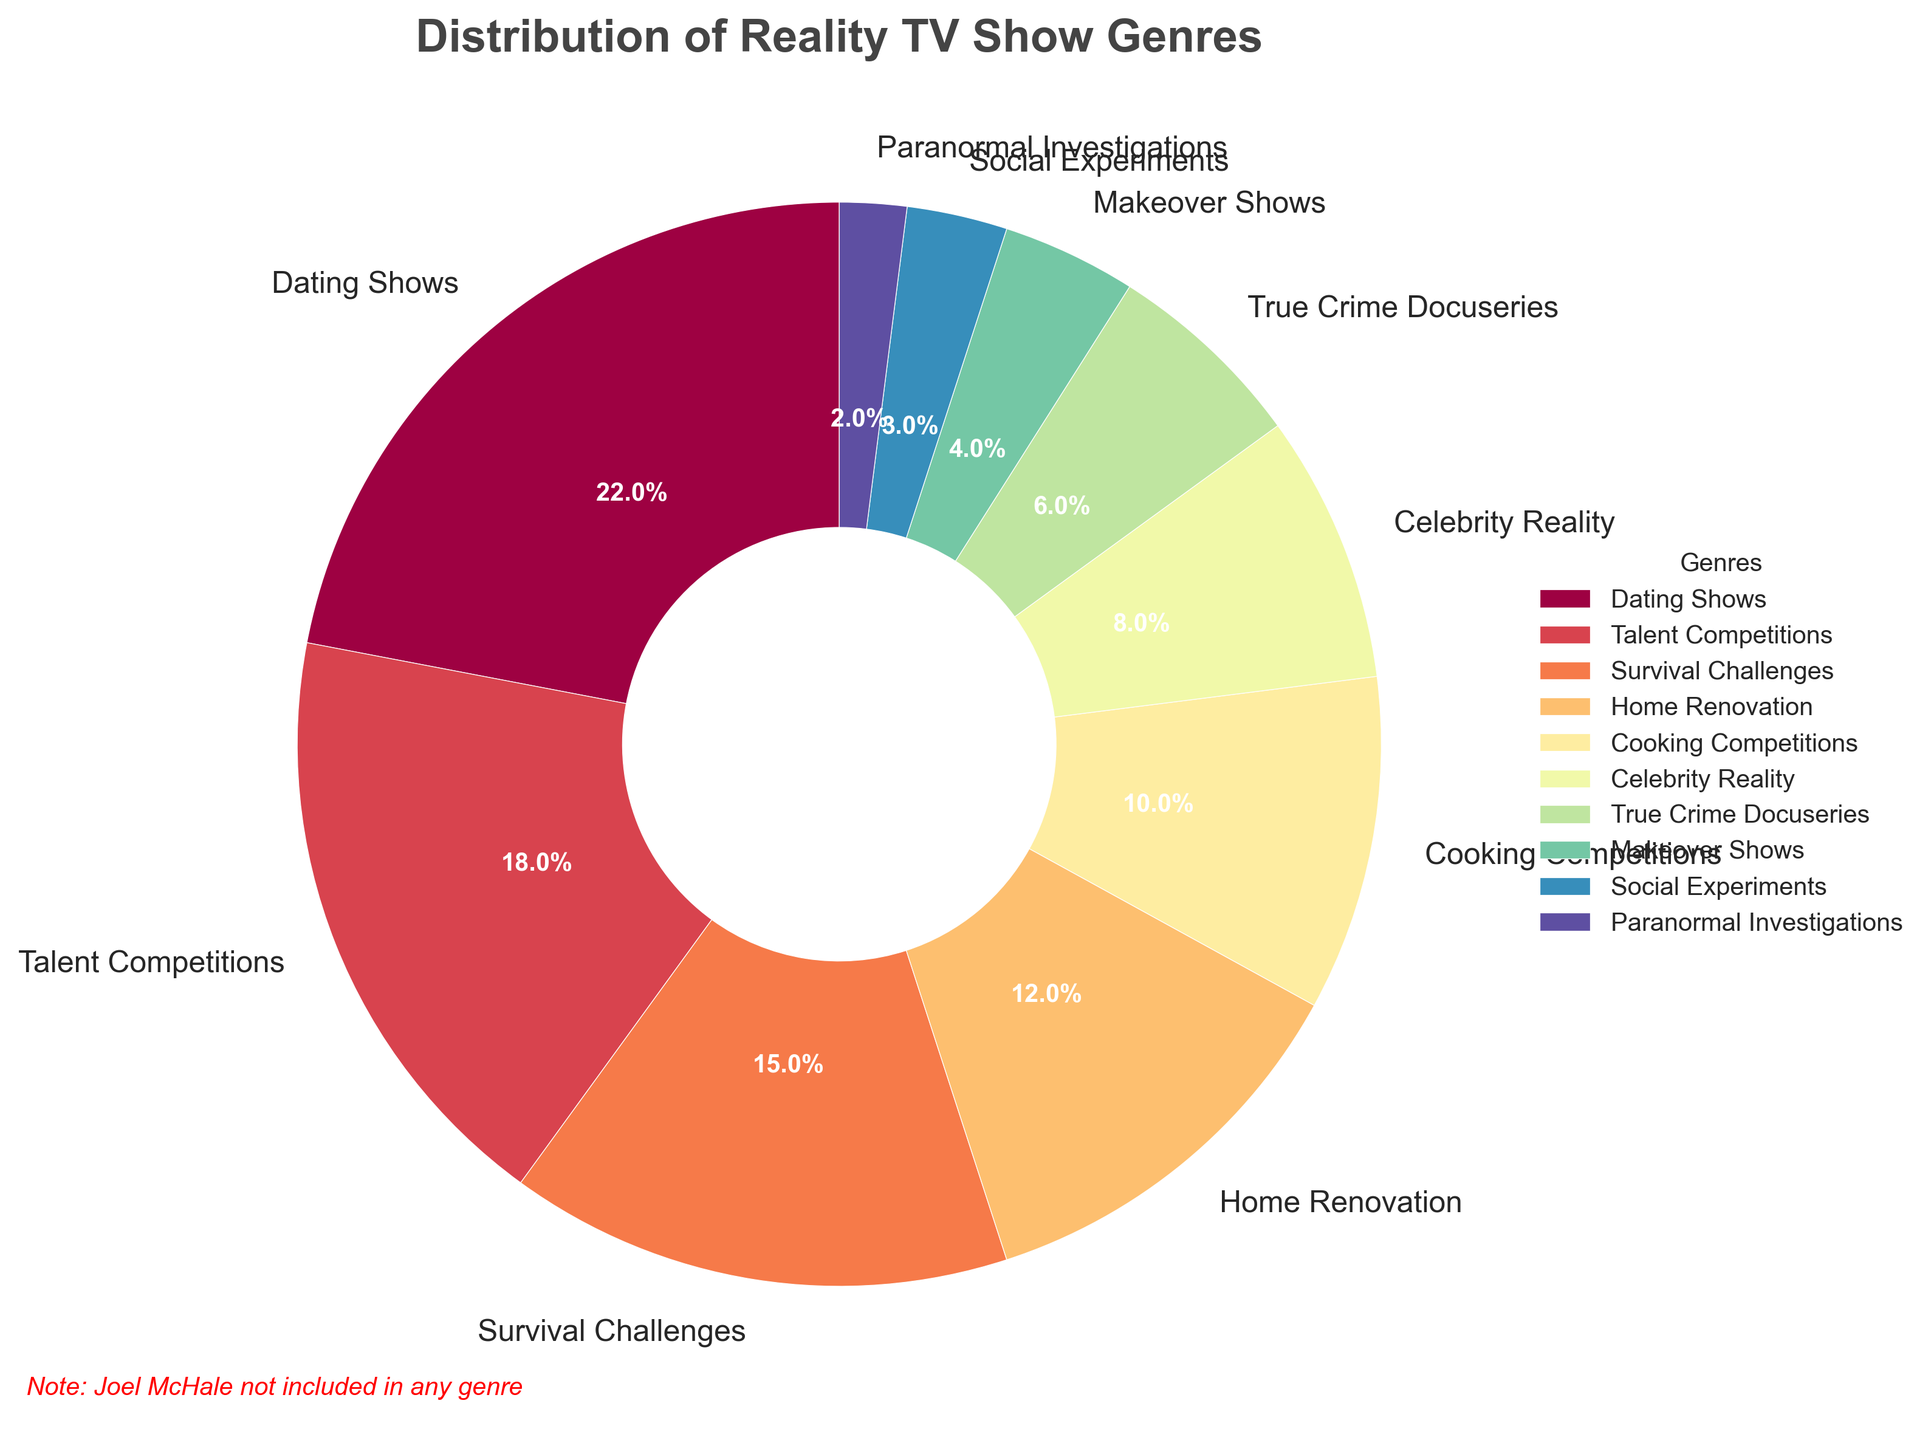Which genre has the highest percentage of viewers? Observe the segments of the pie chart and find the largest one. The largest segment is labeled "Dating Shows" with 22%.
Answer: Dating Shows What's the combined percentage of viewers for Talent Competitions and Cooking Competitions? Identify the percentages for Talent Competitions (18%) and Cooking Competitions (10%). Add these values together (18% + 10% = 28%).
Answer: 28% Which genre has a smaller percentage of viewers, Home Renovation or True Crime Docuseries? Compare the percentages of Home Renovation and True Crime Docuseries. Home Renovation has 12%, while True Crime Docuseries has 6%.
Answer: True Crime Docuseries What is the total percentage of the least popular three genres? The three genres with the smallest percentages are Paranormal Investigations (2%), Social Experiments (3%), and Makeover Shows (4%). Add their percentages together (2% + 3% + 4% = 9%).
Answer: 9% How does the percentage of viewers for Survival Challenges compare to that of Home Renovation? Observe the segments representing Survival Challenges and Home Renovation. Survival Challenges has 15%, and Home Renovation has 12%. Thus, Survival Challenges is larger.
Answer: Survival Challenges larger What is the difference in viewer percentage between Dating Shows and Celebrity Reality shows? Identify the percentages for Dating Shows (22%) and Celebrity Reality (8%). Subtract the smaller value from the larger one (22% - 8% = 14%).
Answer: 14% Are there more viewers for Social Experiments or Makeover Shows, and by how much? Compare the percentages for Social Experiments (3%) and Makeover Shows (4%). Subtract the smaller percentage from the larger one (4% - 3% = 1%).
Answer: Makeover Shows by 1% What is the collective percentage of viewers for genres related to performances (Talent Competitions and Cooking Competitions)? Identify the percentages for Talent Competitions (18%) and Cooking Competitions (10%). Add these values together (18% + 10% = 28%).
Answer: 28% Which genre is twice as popular as True Crime Docuseries? True Crime Docuseries has 6%. Look for a genre with approximately double this percentage. Makeover Shows has 4% + True Crime Docuseries' 6% = 10%, which is close; yet, the exact double doesn't exist in this context. So, next closest, Social Experiments is 3% is half of 6%.
Answer: Social Experiments is half 